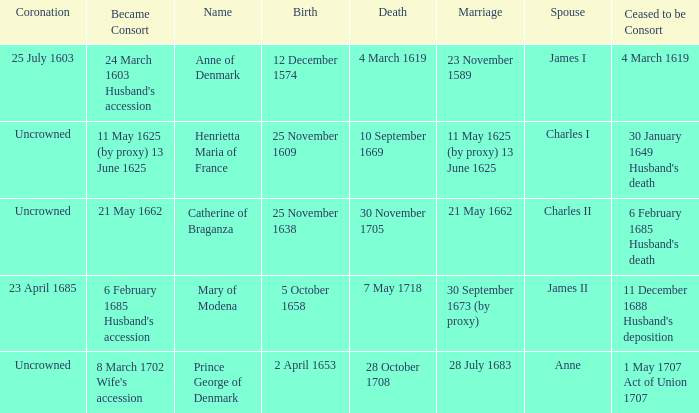On what date did James II take a consort? 6 February 1685 Husband's accession. 